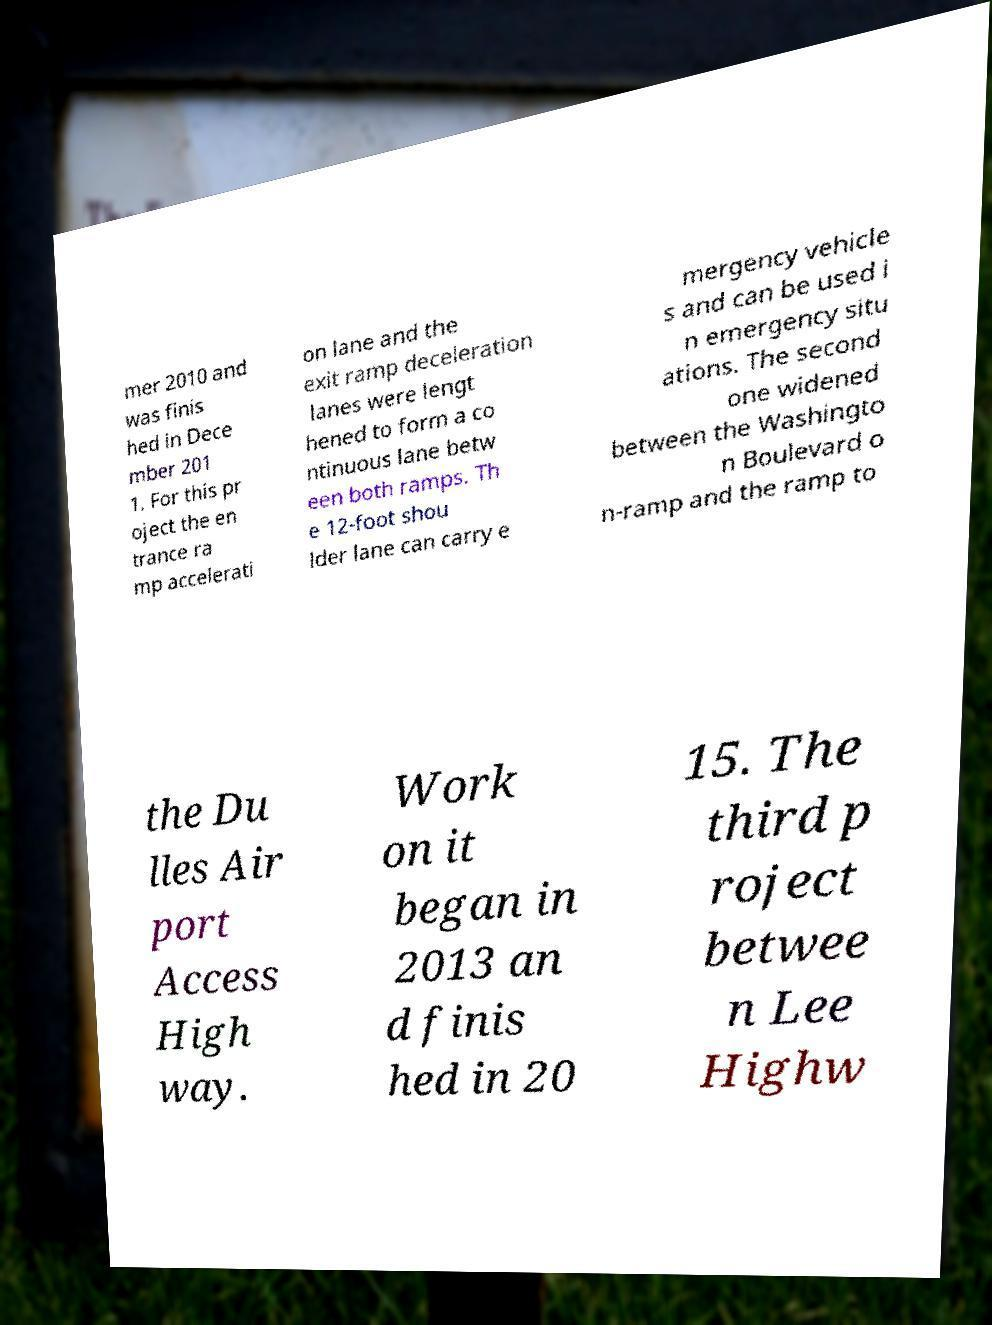What messages or text are displayed in this image? I need them in a readable, typed format. mer 2010 and was finis hed in Dece mber 201 1. For this pr oject the en trance ra mp accelerati on lane and the exit ramp deceleration lanes were lengt hened to form a co ntinuous lane betw een both ramps. Th e 12-foot shou lder lane can carry e mergency vehicle s and can be used i n emergency situ ations. The second one widened between the Washingto n Boulevard o n-ramp and the ramp to the Du lles Air port Access High way. Work on it began in 2013 an d finis hed in 20 15. The third p roject betwee n Lee Highw 